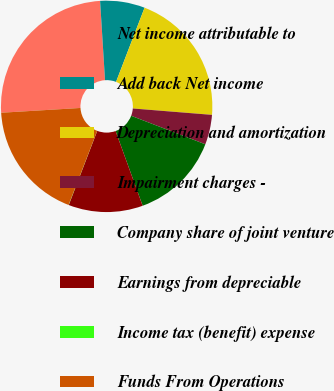<chart> <loc_0><loc_0><loc_500><loc_500><pie_chart><fcel>Net income attributable to<fcel>Add back Net income<fcel>Depreciation and amortization<fcel>Impairment charges -<fcel>Company share of joint venture<fcel>Earnings from depreciable<fcel>Income tax (benefit) expense<fcel>Funds From Operations<nl><fcel>24.97%<fcel>6.83%<fcel>20.44%<fcel>4.56%<fcel>13.63%<fcel>11.37%<fcel>0.03%<fcel>18.17%<nl></chart> 